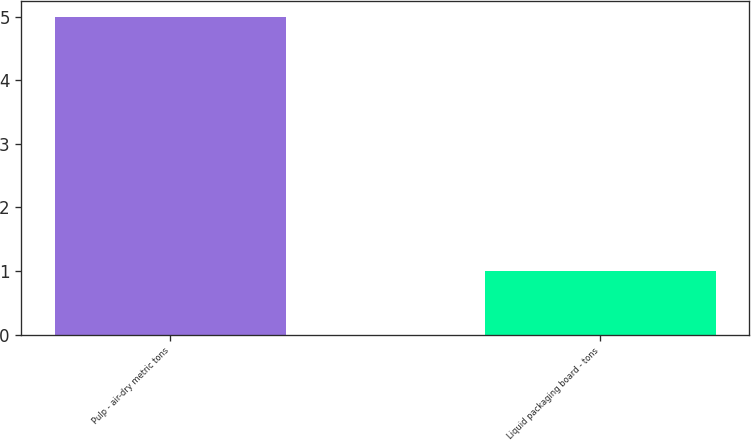Convert chart. <chart><loc_0><loc_0><loc_500><loc_500><bar_chart><fcel>Pulp - air-dry metric tons<fcel>Liquid packaging board - tons<nl><fcel>5<fcel>1<nl></chart> 